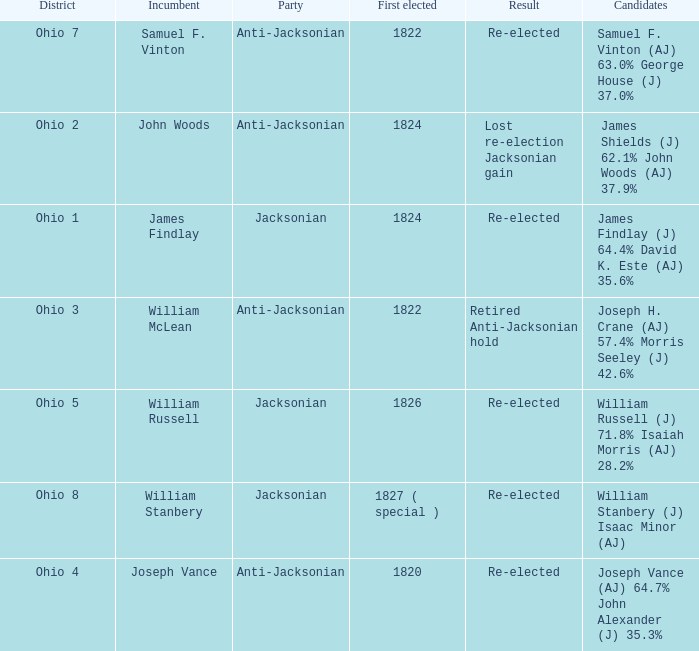What was the result for the candidate first elected in 1820? Re-elected. 